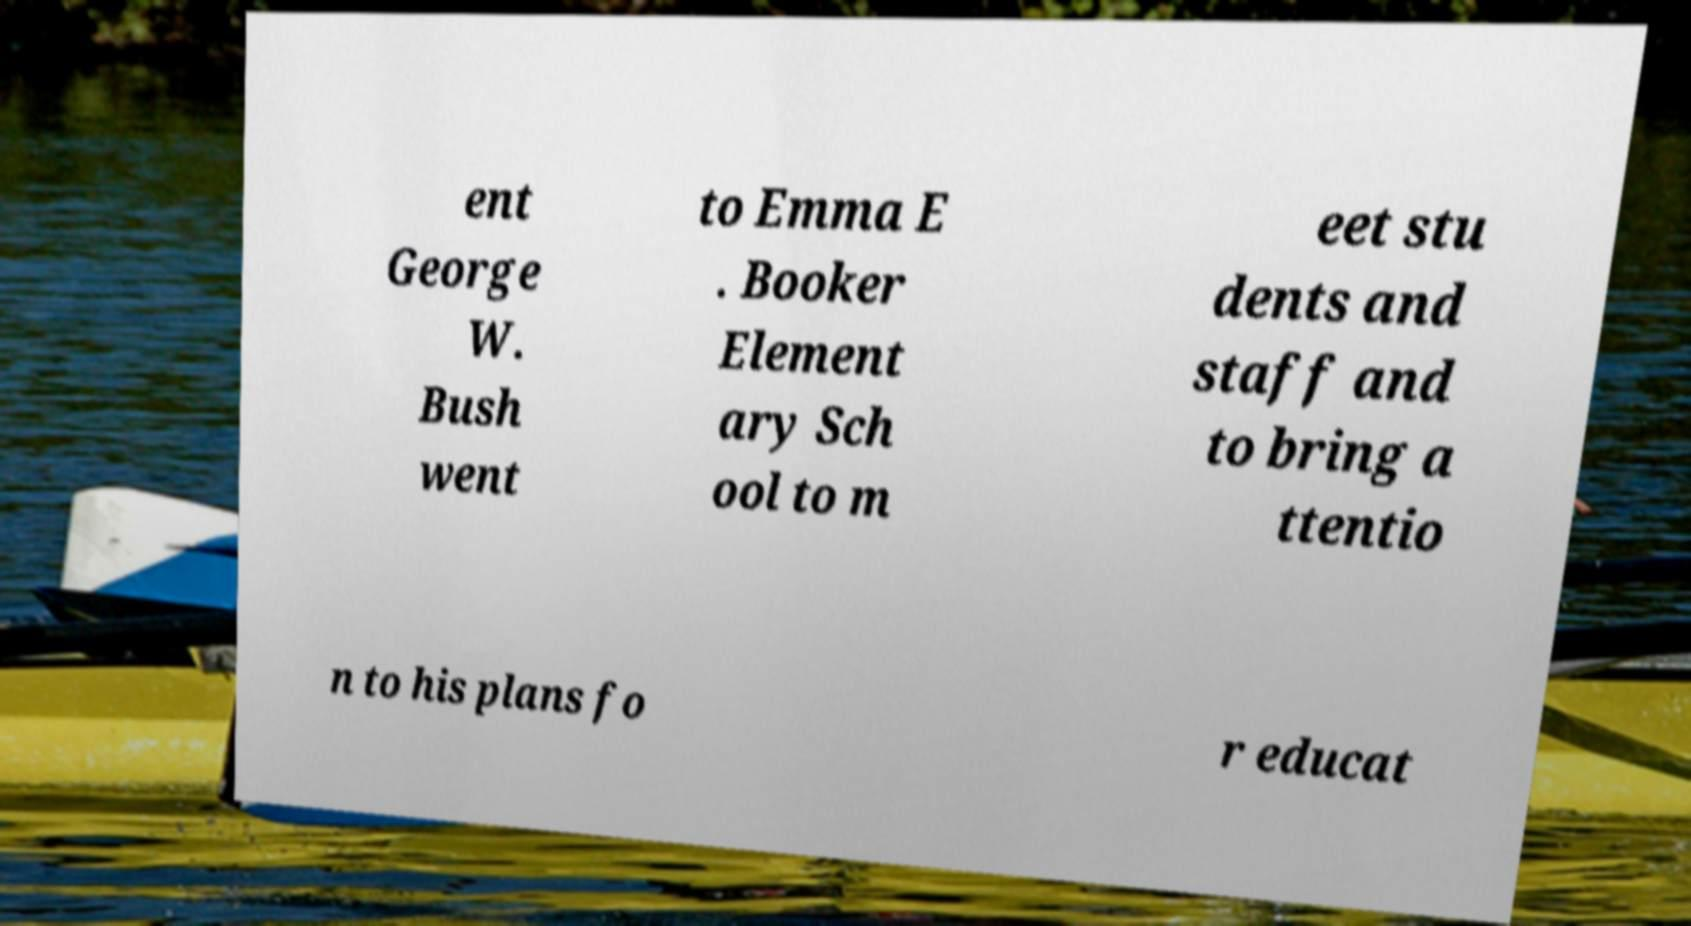Can you accurately transcribe the text from the provided image for me? ent George W. Bush went to Emma E . Booker Element ary Sch ool to m eet stu dents and staff and to bring a ttentio n to his plans fo r educat 